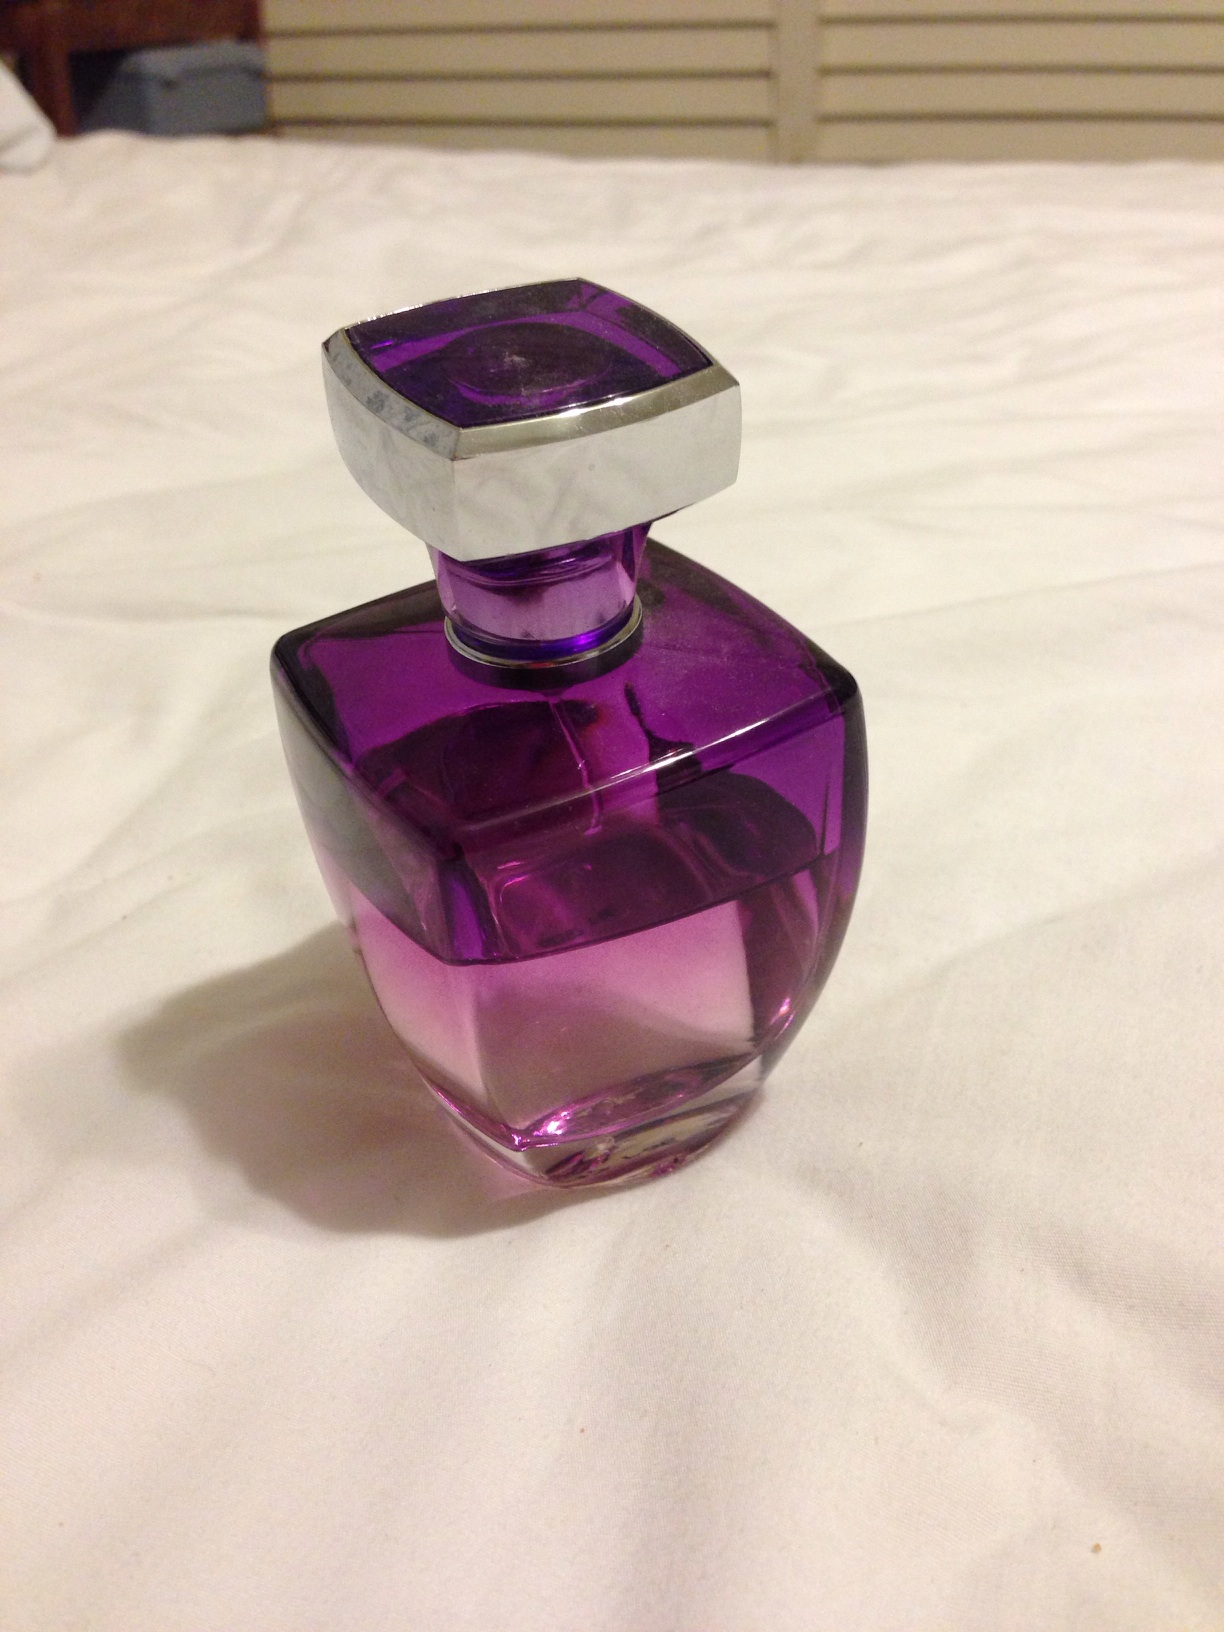What is it? from Vizwiz perfume 